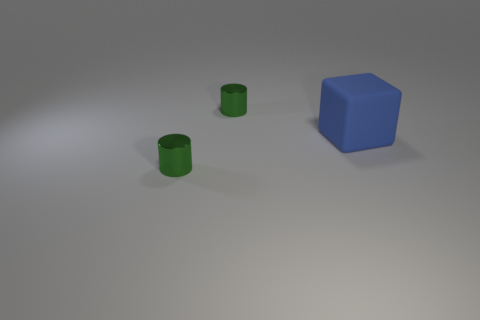What number of tiny objects are blue matte blocks or green metallic objects?
Give a very brief answer. 2. There is a metal cylinder behind the block; what is its size?
Your answer should be very brief. Small. Are there any cylinders of the same color as the matte block?
Provide a short and direct response. No. There is a object in front of the big rubber thing; what number of blue blocks are on the right side of it?
Your answer should be compact. 1. Are there any small green shiny cylinders behind the blue thing?
Make the answer very short. Yes. How many objects are either small green things that are on the left side of the blue object or gray rubber things?
Give a very brief answer. 2. How many other things are there of the same size as the cube?
Provide a succinct answer. 0. What color is the small shiny cylinder that is on the left side of the tiny cylinder on the right side of the green object that is in front of the big rubber object?
Offer a terse response. Green. How many other objects are there of the same shape as the big blue matte thing?
Your answer should be very brief. 0. What is the shape of the object on the right side of the small shiny cylinder behind the tiny green shiny cylinder that is in front of the large blue matte thing?
Keep it short and to the point. Cube. 